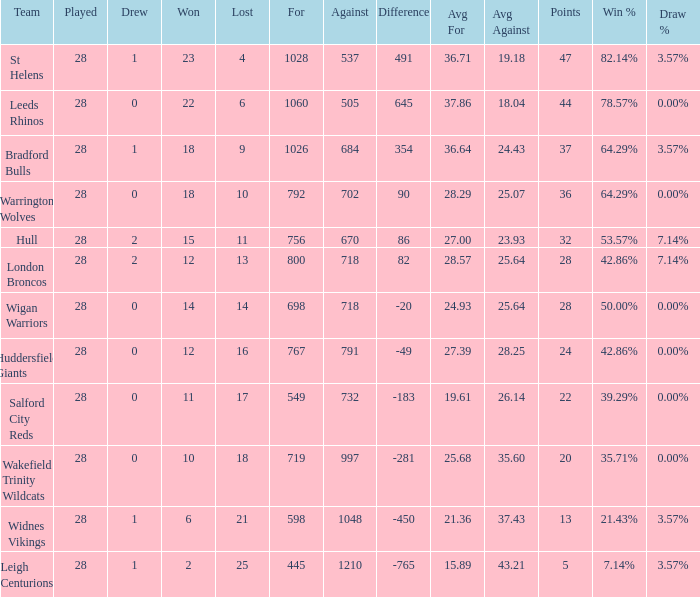What is the most lost games for the team with a difference smaller than 86 and points of 32? None. 